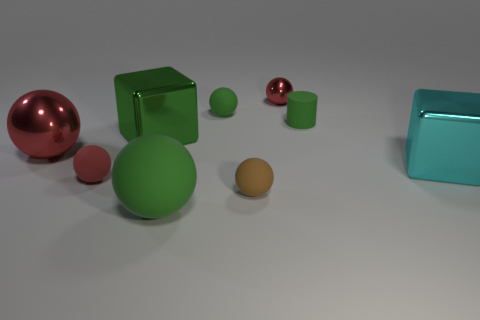What number of green matte balls are there?
Offer a very short reply. 2. What is the color of the large object that is the same material as the tiny brown sphere?
Your answer should be compact. Green. Is the number of large blocks greater than the number of big rubber things?
Ensure brevity in your answer.  Yes. What is the size of the sphere that is right of the small green sphere and in front of the large shiny sphere?
Offer a terse response. Small. There is a big ball that is the same color as the cylinder; what material is it?
Keep it short and to the point. Rubber. Is the number of large green metallic cubes left of the big green metallic object the same as the number of big matte spheres?
Give a very brief answer. No. Is the red rubber thing the same size as the cylinder?
Offer a terse response. Yes. The object that is both on the left side of the small brown rubber sphere and behind the tiny cylinder is what color?
Ensure brevity in your answer.  Green. The block on the right side of the tiny red ball that is behind the big green metallic object is made of what material?
Provide a succinct answer. Metal. There is a brown matte object that is the same shape as the tiny red matte object; what is its size?
Keep it short and to the point. Small. 